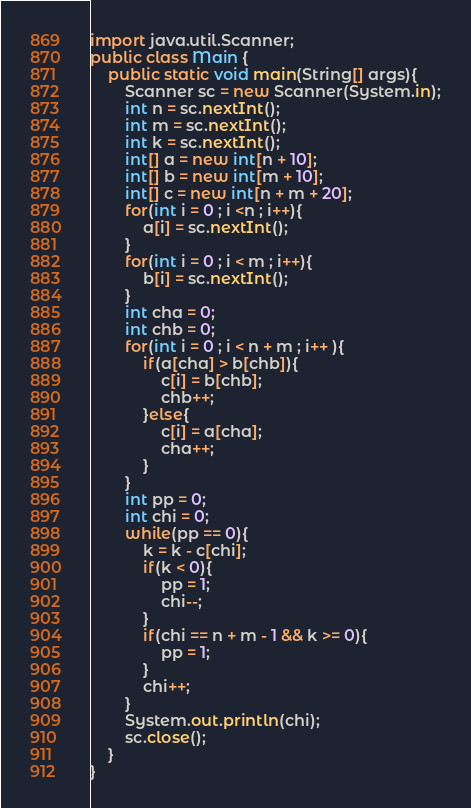Convert code to text. <code><loc_0><loc_0><loc_500><loc_500><_Java_>import java.util.Scanner;
public class Main {
    public static void main(String[] args){
        Scanner sc = new Scanner(System.in);
        int n = sc.nextInt();
        int m = sc.nextInt();
        int k = sc.nextInt();
        int[] a = new int[n + 10];
        int[] b = new int[m + 10];
        int[] c = new int[n + m + 20];
        for(int i = 0 ; i <n ; i++){
            a[i] = sc.nextInt();
        }
        for(int i = 0 ; i < m ; i++){
            b[i] = sc.nextInt();
        }
        int cha = 0;
        int chb = 0; 
        for(int i = 0 ; i < n + m ; i++ ){
            if(a[cha] > b[chb]){
                c[i] = b[chb];
                chb++;
            }else{
                c[i] = a[cha];
                cha++;
            }
        }
        int pp = 0;
        int chi = 0;
        while(pp == 0){
            k = k - c[chi];
            if(k < 0){
                pp = 1;
                chi--;
            }
            if(chi == n + m - 1 && k >= 0){
                pp = 1;
            }
            chi++;
        }
        System.out.println(chi);
        sc.close();
    }
}</code> 